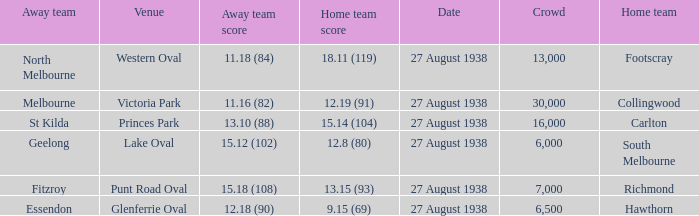What is the average crowd attendance for Collingwood? 30000.0. Would you mind parsing the complete table? {'header': ['Away team', 'Venue', 'Away team score', 'Home team score', 'Date', 'Crowd', 'Home team'], 'rows': [['North Melbourne', 'Western Oval', '11.18 (84)', '18.11 (119)', '27 August 1938', '13,000', 'Footscray'], ['Melbourne', 'Victoria Park', '11.16 (82)', '12.19 (91)', '27 August 1938', '30,000', 'Collingwood'], ['St Kilda', 'Princes Park', '13.10 (88)', '15.14 (104)', '27 August 1938', '16,000', 'Carlton'], ['Geelong', 'Lake Oval', '15.12 (102)', '12.8 (80)', '27 August 1938', '6,000', 'South Melbourne'], ['Fitzroy', 'Punt Road Oval', '15.18 (108)', '13.15 (93)', '27 August 1938', '7,000', 'Richmond'], ['Essendon', 'Glenferrie Oval', '12.18 (90)', '9.15 (69)', '27 August 1938', '6,500', 'Hawthorn']]} 